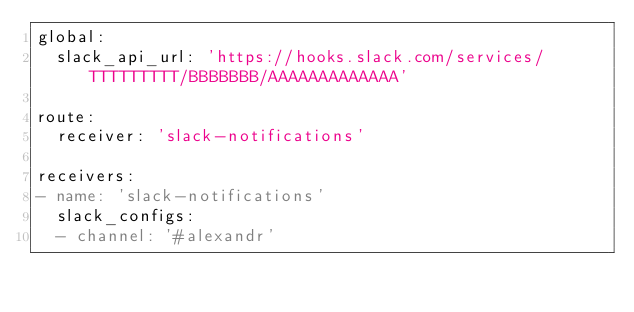<code> <loc_0><loc_0><loc_500><loc_500><_YAML_>global:
  slack_api_url: 'https://hooks.slack.com/services/TTTTTTTTT/BBBBBBB/AAAAAAAAAAAAA'

route:
  receiver: 'slack-notifications'

receivers:
- name: 'slack-notifications'
  slack_configs:
  - channel: '#alexandr'
</code> 